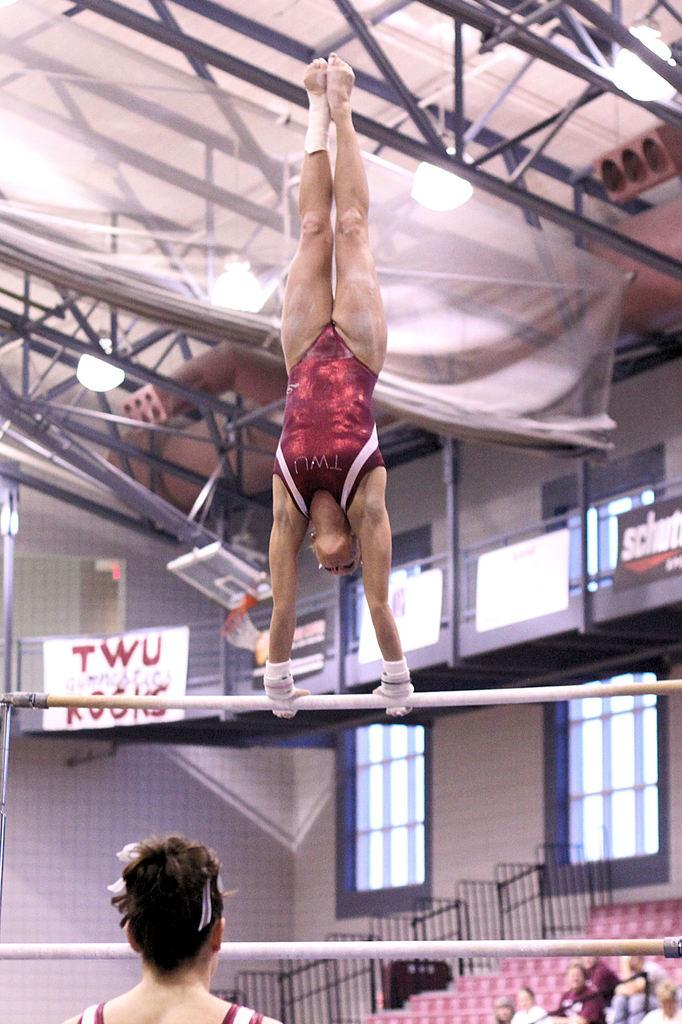Provide a one-sentence caption for the provided image. A gymnast doing a handstand on the bars in the TWU gym. 